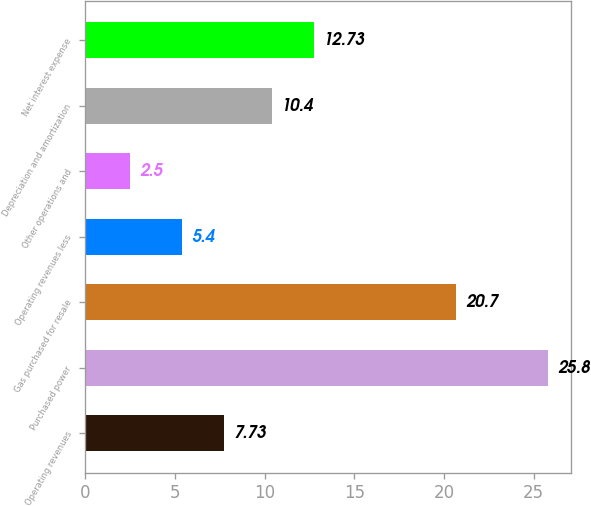Convert chart. <chart><loc_0><loc_0><loc_500><loc_500><bar_chart><fcel>Operating revenues<fcel>Purchased power<fcel>Gas purchased for resale<fcel>Operating revenues less<fcel>Other operations and<fcel>Depreciation and amortization<fcel>Net interest expense<nl><fcel>7.73<fcel>25.8<fcel>20.7<fcel>5.4<fcel>2.5<fcel>10.4<fcel>12.73<nl></chart> 